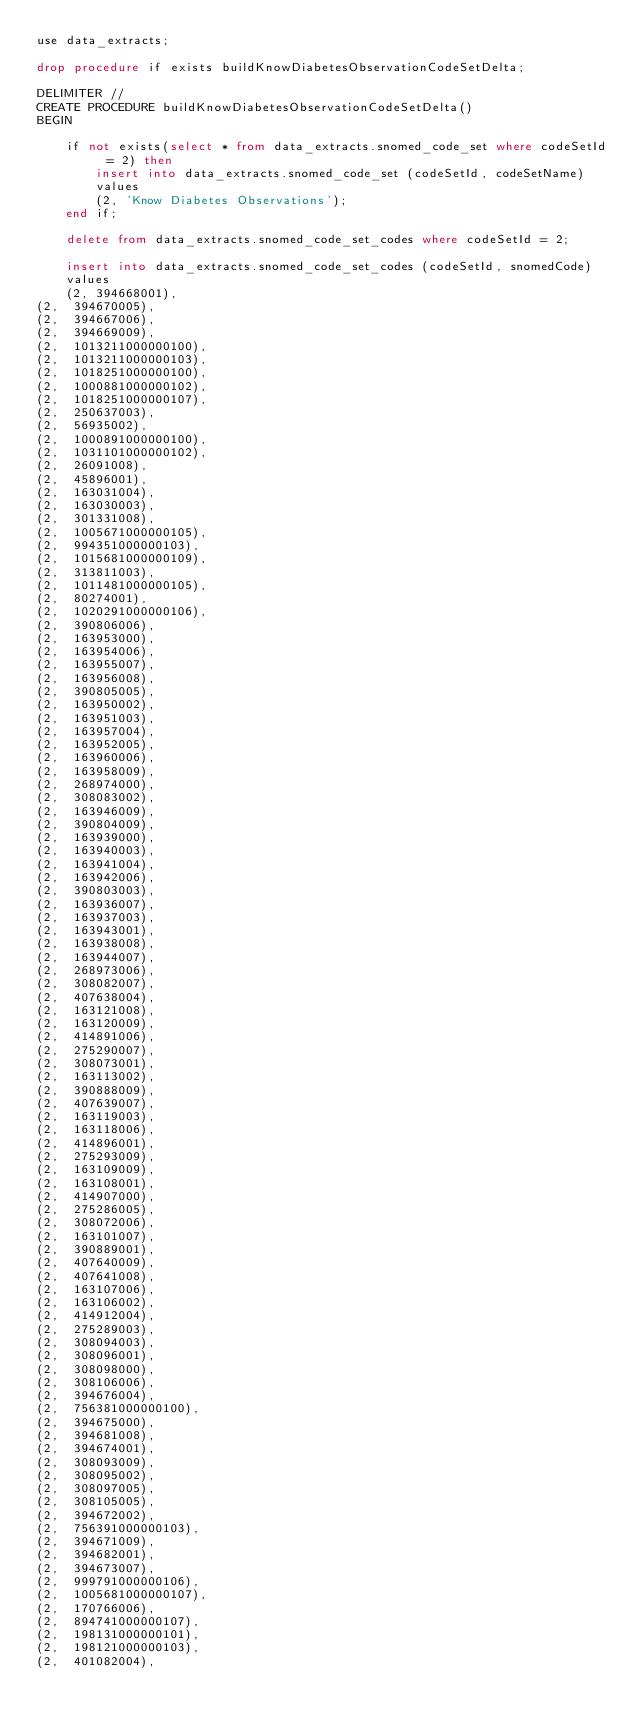Convert code to text. <code><loc_0><loc_0><loc_500><loc_500><_SQL_>use data_extracts;

drop procedure if exists buildKnowDiabetesObservationCodeSetDelta;

DELIMITER //
CREATE PROCEDURE buildKnowDiabetesObservationCodeSetDelta()
BEGIN

	if not exists(select * from data_extracts.snomed_code_set where codeSetId = 2) then
		insert into data_extracts.snomed_code_set (codeSetId, codeSetName)
		values
		(2, 'Know Diabetes Observations');
    end if;

	delete from data_extracts.snomed_code_set_codes where codeSetId = 2;

	insert into data_extracts.snomed_code_set_codes (codeSetId, snomedCode)
	values
	(2, 394668001),
(2,  394670005),
(2,  394667006),
(2,  394669009),
(2,  1013211000000100),
(2,  1013211000000103),
(2,  1018251000000100),
(2,  1000881000000102),
(2,  1018251000000107),
(2,  250637003),
(2,  56935002),
(2,  1000891000000100),
(2,  1031101000000102),
(2,  26091008),
(2,  45896001),
(2,  163031004),
(2,  163030003),
(2,  301331008),
(2,  1005671000000105),
(2,  994351000000103),
(2,  1015681000000109),
(2,  313811003),
(2,  1011481000000105),
(2,  80274001),
(2,  1020291000000106),
(2,  390806006),
(2,  163953000),
(2,  163954006),
(2,  163955007),
(2,  163956008),
(2,  390805005),
(2,  163950002),
(2,  163951003),
(2,  163957004),
(2,  163952005),
(2,  163960006),
(2,  163958009),
(2,  268974000),
(2,  308083002),
(2,  163946009),
(2,  390804009),
(2,  163939000),
(2,  163940003),
(2,  163941004),
(2,  163942006),
(2,  390803003),
(2,  163936007),
(2,  163937003),
(2,  163943001),
(2,  163938008),
(2,  163944007),
(2,  268973006),
(2,  308082007),
(2,  407638004),
(2,  163121008),
(2,  163120009),
(2,  414891006),
(2,  275290007),
(2,  308073001),
(2,  163113002),
(2,  390888009),
(2,  407639007),
(2,  163119003),
(2,  163118006),
(2,  414896001),
(2,  275293009),
(2,  163109009),
(2,  163108001),
(2,  414907000),
(2,  275286005),
(2,  308072006),
(2,  163101007),
(2,  390889001),
(2,  407640009),
(2,  407641008),
(2,  163107006),
(2,  163106002),
(2,  414912004),
(2,  275289003),
(2,  308094003),
(2,  308096001),
(2,  308098000),
(2,  308106006),
(2,  394676004),
(2,  756381000000100),
(2,  394675000),
(2,  394681008),
(2,  394674001),
(2,  308093009),
(2,  308095002),
(2,  308097005),
(2,  308105005),
(2,  394672002),
(2,  756391000000103),
(2,  394671009),
(2,  394682001),
(2,  394673007),
(2,  999791000000106),
(2,  1005681000000107),
(2,  170766006),
(2,  894741000000107),
(2,  198131000000101),
(2,  198121000000103),
(2,  401082004),</code> 